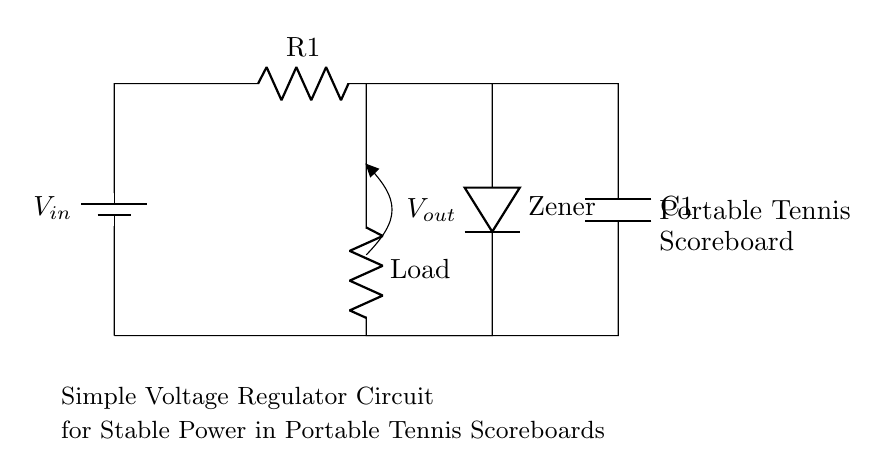What is the input voltage in the circuit? The input voltage is labeled as V in, which indicates the input power source for the circuit.
Answer: V in What type of resistor is labeled as R1? R1 is a standard resistor that limits the current through the circuit; it is drawn in series with the load.
Answer: Resistor What is the purpose of the Zener diode in this circuit? The Zener diode regulates the output voltage by allowing current to flow backward when the voltage exceeds a certain level, maintaining a stable voltage supply for the load.
Answer: Voltage regulation What is the value of the output voltage at V out? V out represents the regulated output voltage provided to the load, maintained by the Zener diode's characteristics.
Answer: Zener voltage How many components are in this circuit? The circuit includes a battery, two resistors, a Zener diode, and a capacitor, totaling five key components.
Answer: Five Where is the load connected in this circuit? The load is connected in parallel with the Zener diode and the capacitor, drawing regulated power when needed.
Answer: Parallel to Zener and capacitor What is the role of the capacitor C1? C1 acts as a filter capacitor, providing stability to the output voltage by smoothing out fluctuations in the current supplied to the load.
Answer: Smoothing fluctuations 